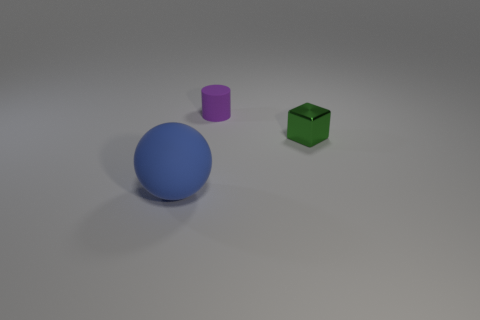Add 1 big brown matte things. How many objects exist? 4 Subtract all spheres. How many objects are left? 2 Add 3 cylinders. How many cylinders are left? 4 Add 1 tiny green cubes. How many tiny green cubes exist? 2 Subtract 0 red cubes. How many objects are left? 3 Subtract all purple things. Subtract all big metallic cylinders. How many objects are left? 2 